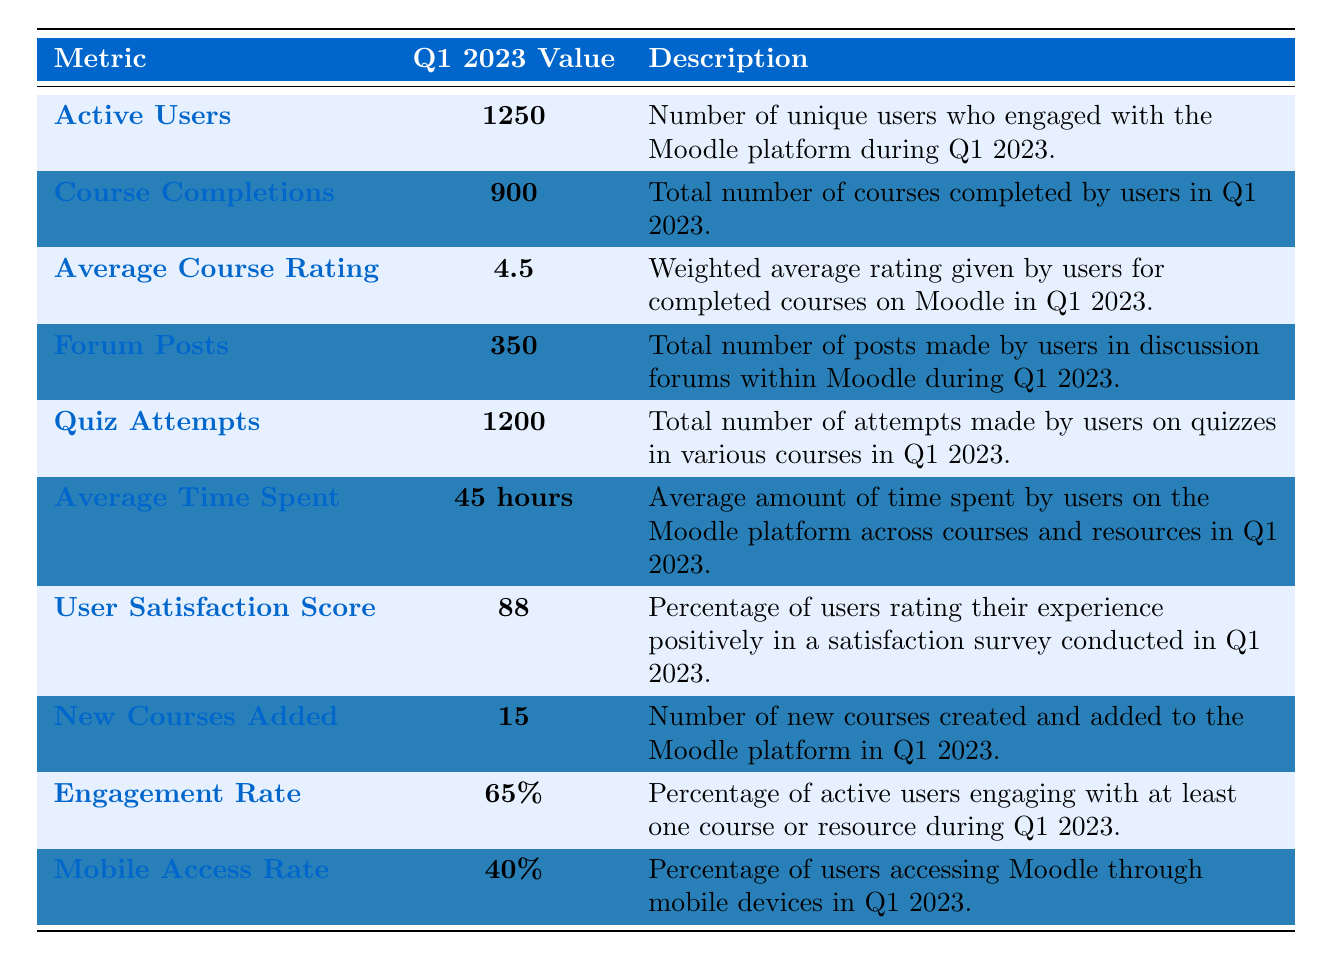What is the total number of Active Users in Q1 2023? The table lists Active Users with a corresponding value of 1250 for Q1 2023.
Answer: 1250 How many Course Completions were recorded in Q1 2023? According to the table, the number of Course Completions is 900 in Q1 2023.
Answer: 900 What is the Average Course Rating given by users? The Average Course Rating listed in the table for Q1 2023 is 4.5.
Answer: 4.5 How many Forum Posts were made in Q1 2023? The total number of Forum Posts shown in the table for Q1 2023 is 350.
Answer: 350 What is the total number of Quiz Attempts made by users in Q1 2023? The table indicates that there were 1200 Quiz Attempts during Q1 2023.
Answer: 1200 What is the Average Time Spent by users on the Moodle platform in hours? The Average Time Spent is stated as 45 hours in the table for Q1 2023.
Answer: 45 hours What percentage of users rated their experience positively in Q1 2023? The User Satisfaction Score in the table shows that 88% of users rated their experience positively.
Answer: 88% How many new courses were added to Moodle in Q1 2023? The table indicates that 15 New Courses were added in Q1 2023.
Answer: 15 What is the Engagement Rate for active users during Q1 2023? The Engagement Rate listed in the table is 65% for Q1 2023.
Answer: 65% What is the Mobile Access Rate in Q1 2023? The Mobile Access Rate provided in the table shows that 40% of users accessed Moodle through mobile devices.
Answer: 40% What is the total number of Forum Posts and Course Completions in Q1 2023? Adding Forum Posts (350) and Course Completions (900) gives a total of 1250 (350 + 900 = 1250).
Answer: 1250 What is the difference between the number of Quiz Attempts and Course Completions? The difference is calculated by subtracting Course Completions (900) from Quiz Attempts (1200), resulting in 300 (1200 - 900 = 300).
Answer: 300 What is the average of Active Users and New Courses Added in Q1 2023? To find the average, sum Active Users (1250) and New Courses (15) to get 1265, then divide by 2, resulting in 632.5 (1265/2 = 632.5).
Answer: 632.5 Is the User Satisfaction Score above 80% in Q1 2023? The User Satisfaction Score of 88% exceeds 80%, so the answer is yes.
Answer: Yes If the average time users spent is 45 hours and the Engagement Rate is 65%, what does this imply about user engagement? The average time spent indicates active participation; combined with a 65% Engagement Rate, it suggests a significant portion of users are consistently engaging with the content, leading to both a good average and a high engagement rate.
Answer: High engagement is implied How does the number of Active Users compare to the Mobile Access Rate in terms of absolute numbers? There are 1250 Active Users, while 40% of users accessed the platform via mobile; calculating mobile access gives 500 users (1250 * 0.4 = 500), showing that mobile users are a significant subset of the total.
Answer: Mobile users are 500 